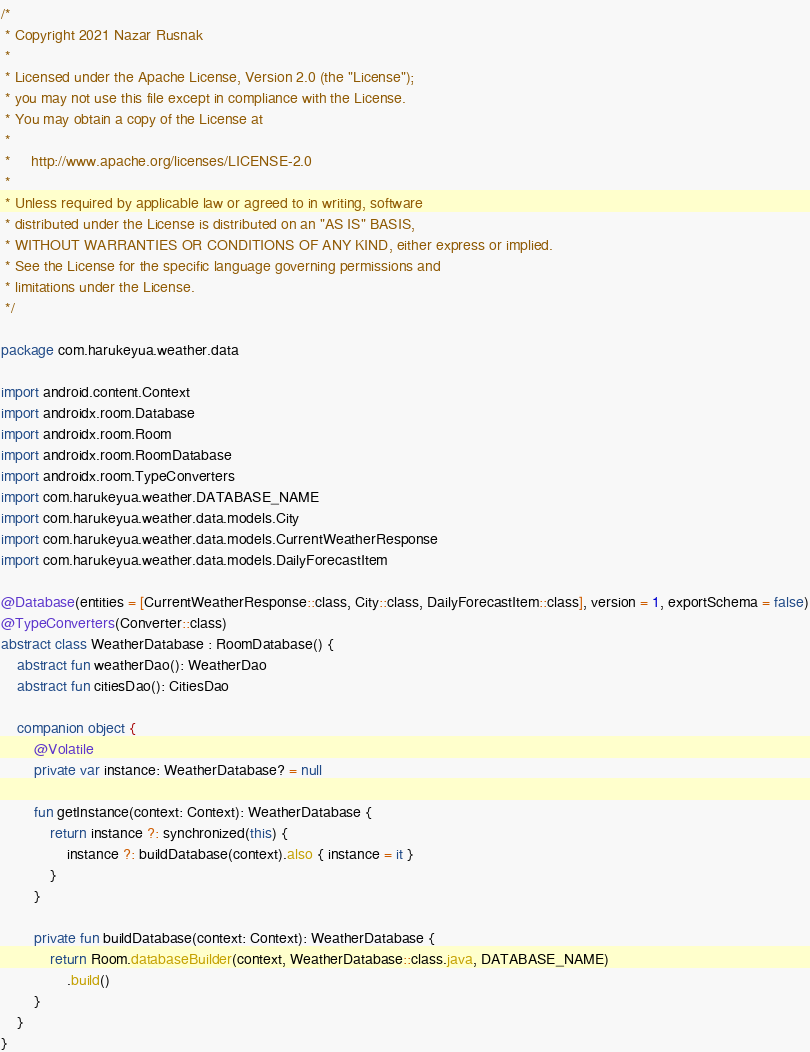Convert code to text. <code><loc_0><loc_0><loc_500><loc_500><_Kotlin_>/*
 * Copyright 2021 Nazar Rusnak
 *
 * Licensed under the Apache License, Version 2.0 (the "License");
 * you may not use this file except in compliance with the License.
 * You may obtain a copy of the License at
 *
 *     http://www.apache.org/licenses/LICENSE-2.0
 *
 * Unless required by applicable law or agreed to in writing, software
 * distributed under the License is distributed on an "AS IS" BASIS,
 * WITHOUT WARRANTIES OR CONDITIONS OF ANY KIND, either express or implied.
 * See the License for the specific language governing permissions and
 * limitations under the License.
 */

package com.harukeyua.weather.data

import android.content.Context
import androidx.room.Database
import androidx.room.Room
import androidx.room.RoomDatabase
import androidx.room.TypeConverters
import com.harukeyua.weather.DATABASE_NAME
import com.harukeyua.weather.data.models.City
import com.harukeyua.weather.data.models.CurrentWeatherResponse
import com.harukeyua.weather.data.models.DailyForecastItem

@Database(entities = [CurrentWeatherResponse::class, City::class, DailyForecastItem::class], version = 1, exportSchema = false)
@TypeConverters(Converter::class)
abstract class WeatherDatabase : RoomDatabase() {
    abstract fun weatherDao(): WeatherDao
    abstract fun citiesDao(): CitiesDao

    companion object {
        @Volatile
        private var instance: WeatherDatabase? = null

        fun getInstance(context: Context): WeatherDatabase {
            return instance ?: synchronized(this) {
                instance ?: buildDatabase(context).also { instance = it }
            }
        }

        private fun buildDatabase(context: Context): WeatherDatabase {
            return Room.databaseBuilder(context, WeatherDatabase::class.java, DATABASE_NAME)
                .build()
        }
    }
}</code> 